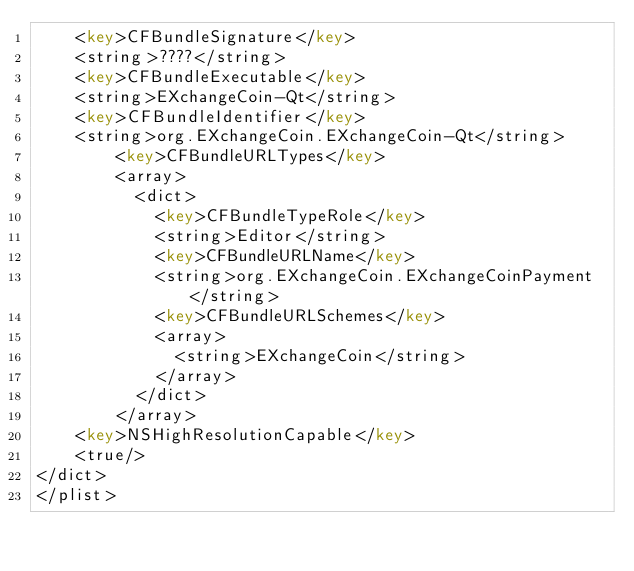Convert code to text. <code><loc_0><loc_0><loc_500><loc_500><_XML_>	<key>CFBundleSignature</key>
	<string>????</string>
	<key>CFBundleExecutable</key>
	<string>EXchangeCoin-Qt</string>
	<key>CFBundleIdentifier</key>
	<string>org.EXchangeCoin.EXchangeCoin-Qt</string>
        <key>CFBundleURLTypes</key>
        <array>
          <dict>
            <key>CFBundleTypeRole</key>
            <string>Editor</string>
            <key>CFBundleURLName</key>
            <string>org.EXchangeCoin.EXchangeCoinPayment</string>
            <key>CFBundleURLSchemes</key>
            <array>
              <string>EXchangeCoin</string>
            </array>
          </dict>
        </array>
	<key>NSHighResolutionCapable</key>
	<true/>
</dict>
</plist>
</code> 